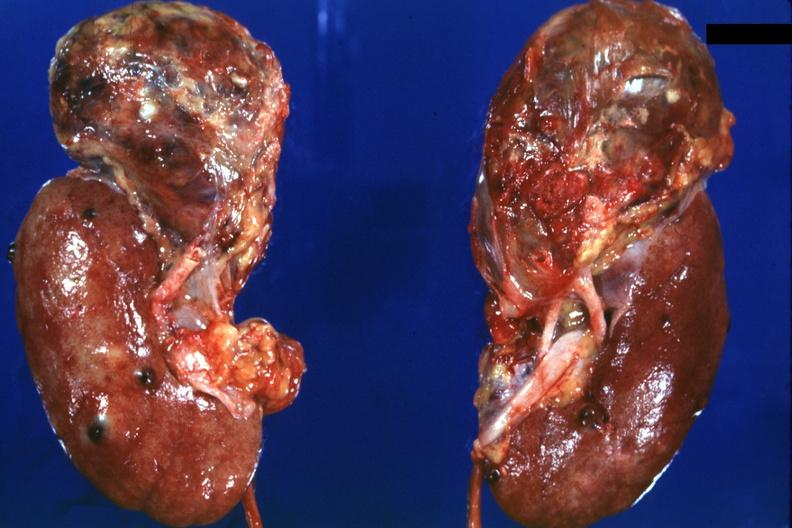where is this?
Answer the question using a single word or phrase. Urinary 